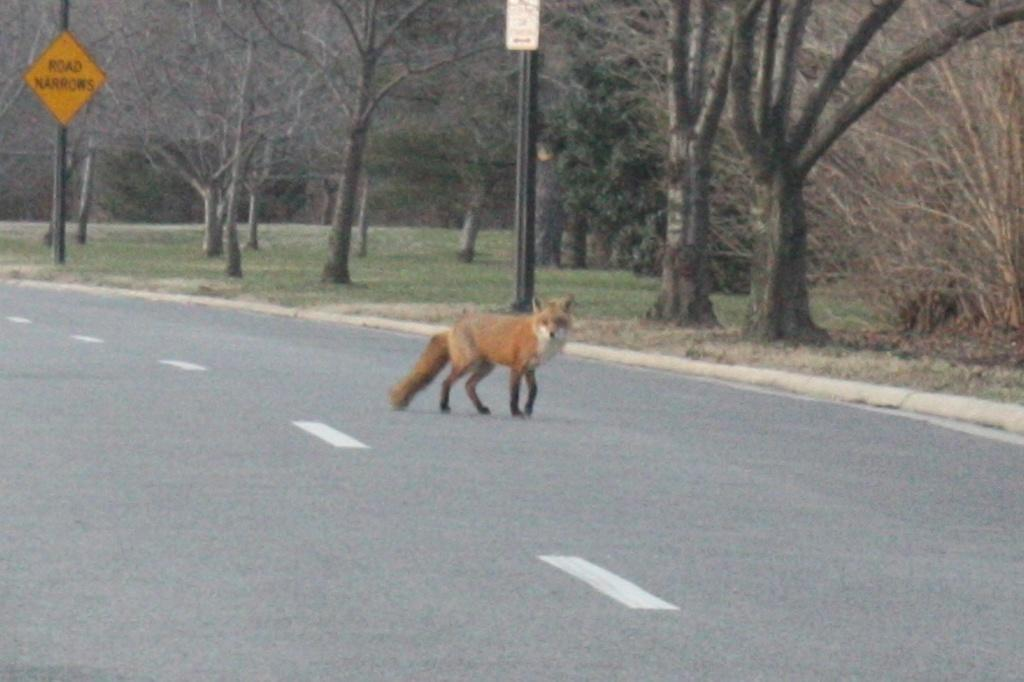What animal is present in the image? There is a fox in the image. Where is the fox located? The fox is on the road. What can be seen in the background of the image? There are boards on poles, grass, trees, and other unspecified objects visible in the background of the image. What type of drum can be heard playing in the background of the image? There is no drum present or audible in the image; it is a visual representation of a fox on the road with a background of boards on poles, grass, trees, and other unspecified objects. 